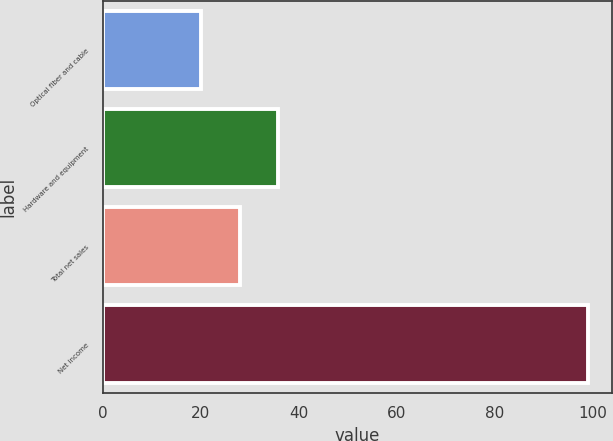<chart> <loc_0><loc_0><loc_500><loc_500><bar_chart><fcel>Optical fiber and cable<fcel>Hardware and equipment<fcel>Total net sales<fcel>Net income<nl><fcel>20<fcel>35.8<fcel>27.9<fcel>99<nl></chart> 